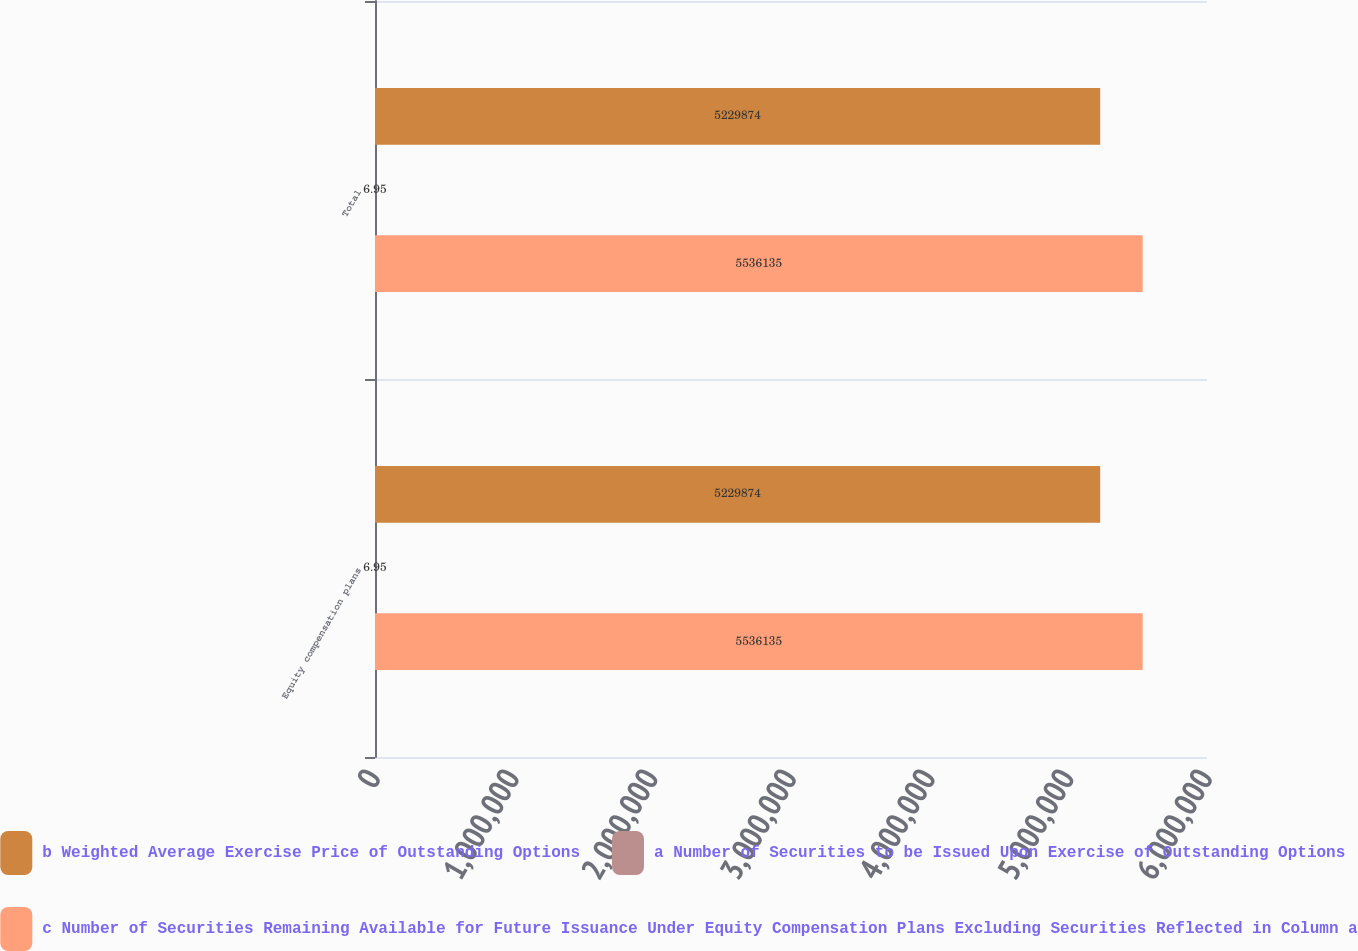<chart> <loc_0><loc_0><loc_500><loc_500><stacked_bar_chart><ecel><fcel>Equity compensation plans<fcel>Total<nl><fcel>b Weighted Average Exercise Price of Outstanding Options<fcel>5.22987e+06<fcel>5.22987e+06<nl><fcel>a Number of Securities to be Issued Upon Exercise of Outstanding Options<fcel>6.95<fcel>6.95<nl><fcel>c Number of Securities Remaining Available for Future Issuance Under Equity Compensation Plans Excluding Securities Reflected in Column a<fcel>5.53614e+06<fcel>5.53614e+06<nl></chart> 